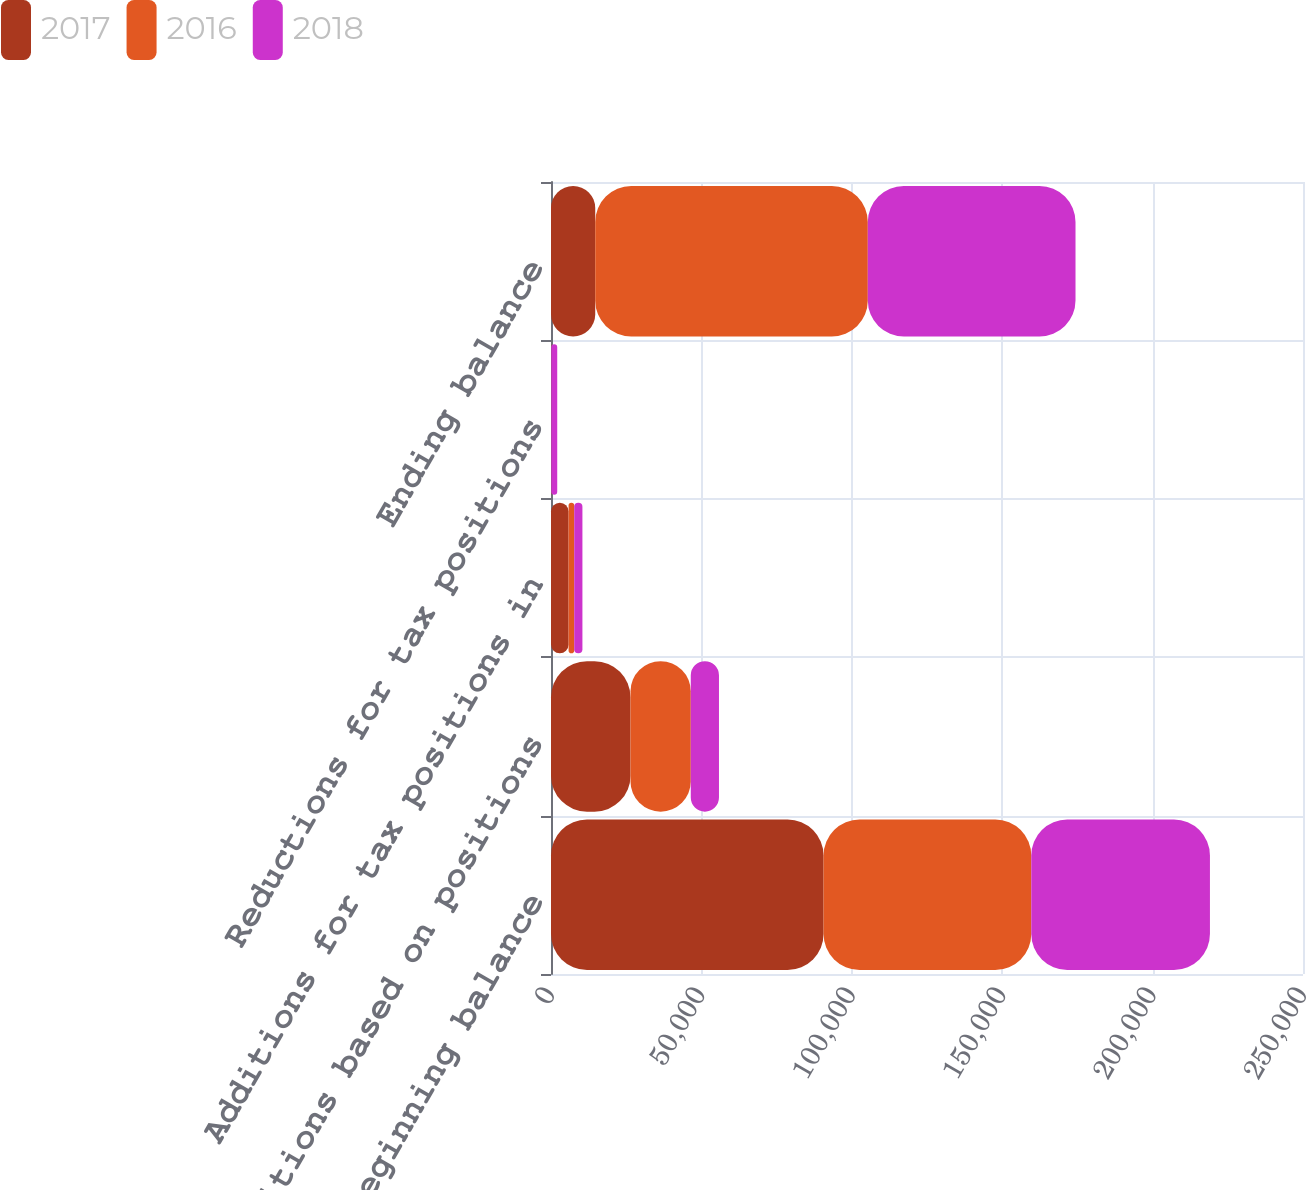Convert chart. <chart><loc_0><loc_0><loc_500><loc_500><stacked_bar_chart><ecel><fcel>Beginning balance<fcel>Additions based on positions<fcel>Additions for tax positions in<fcel>Reductions for tax positions<fcel>Ending balance<nl><fcel>2017<fcel>90615<fcel>26431<fcel>5844<fcel>67<fcel>14705<nl><fcel>2016<fcel>69052<fcel>20036<fcel>1878<fcel>29<fcel>90615<nl><fcel>2018<fcel>59397<fcel>9374<fcel>2723<fcel>1973<fcel>69052<nl></chart> 